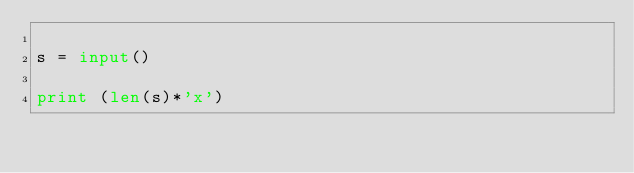Convert code to text. <code><loc_0><loc_0><loc_500><loc_500><_Python_>
s = input()

print (len(s)*'x')

</code> 